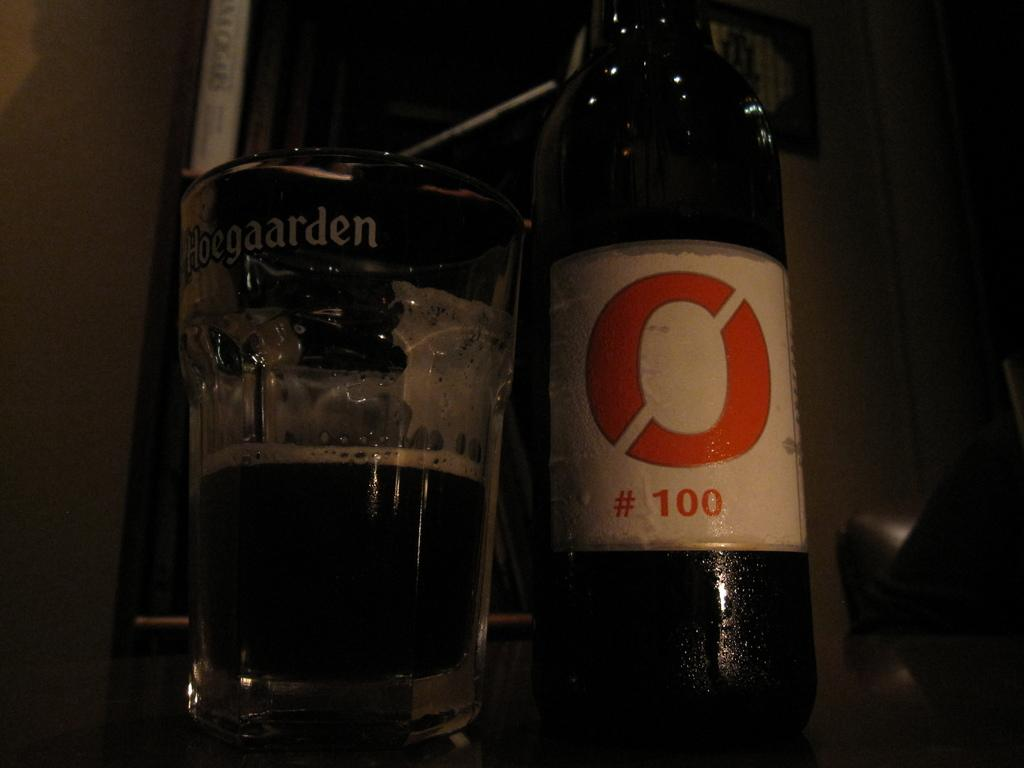<image>
Summarize the visual content of the image. A bottle with the number 100 on it is sitting next to a glass that says Hoegaarden. 